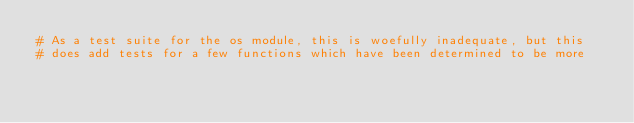Convert code to text. <code><loc_0><loc_0><loc_500><loc_500><_Python_># As a test suite for the os module, this is woefully inadequate, but this
# does add tests for a few functions which have been determined to be more</code> 